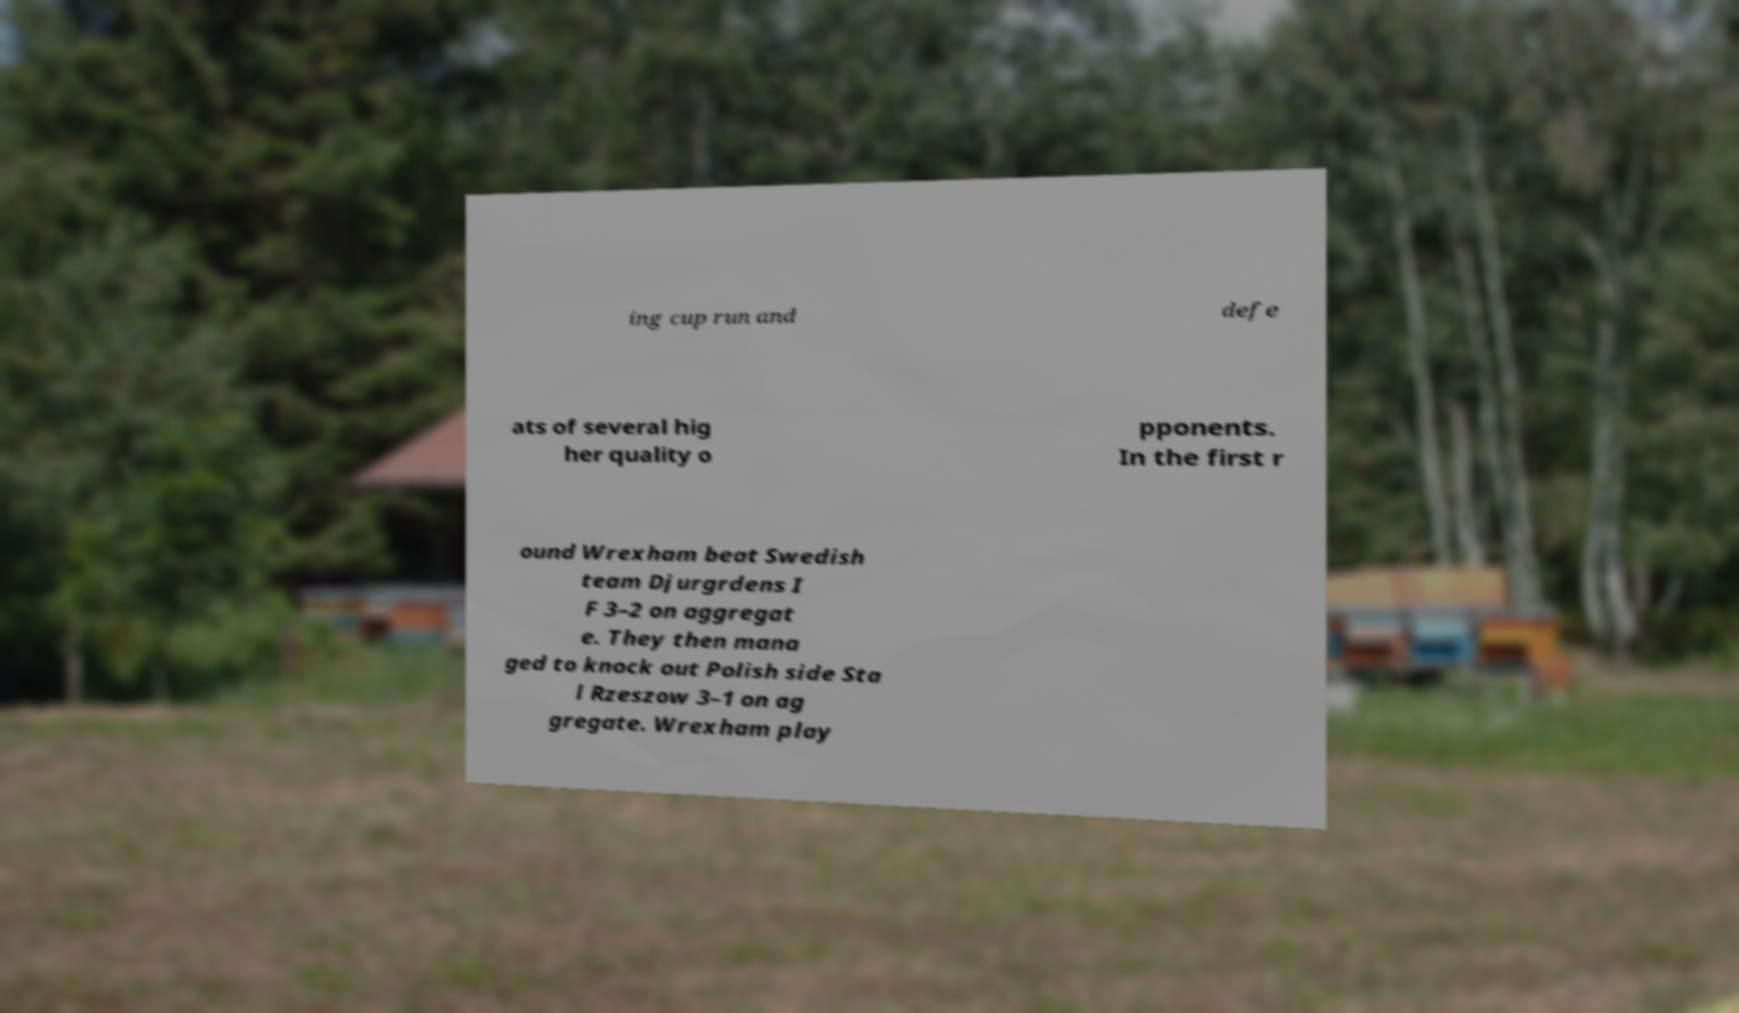Can you read and provide the text displayed in the image?This photo seems to have some interesting text. Can you extract and type it out for me? ing cup run and defe ats of several hig her quality o pponents. In the first r ound Wrexham beat Swedish team Djurgrdens I F 3–2 on aggregat e. They then mana ged to knock out Polish side Sta l Rzeszow 3–1 on ag gregate. Wrexham play 